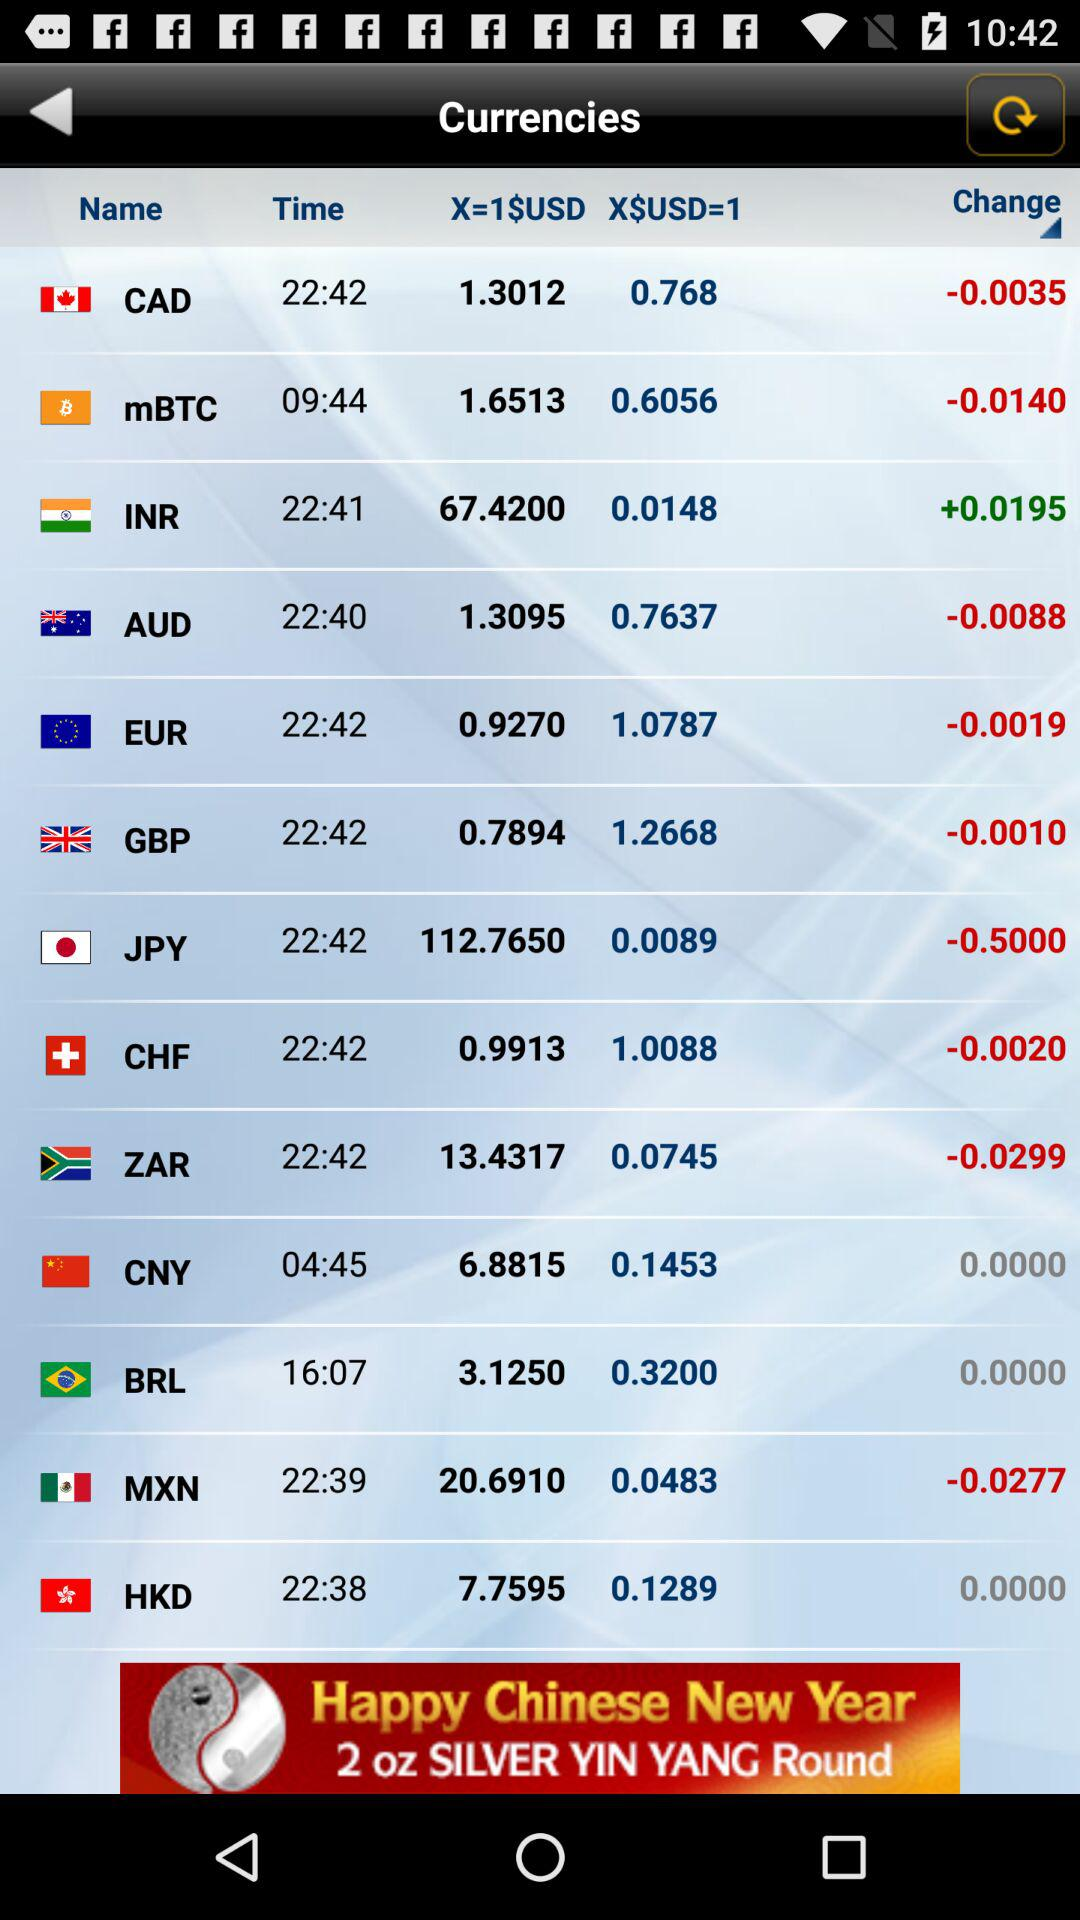How much 1 USD equals to 1 EUR? The value is 0.9270. 